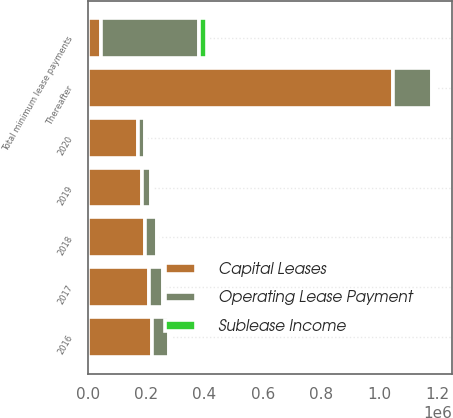Convert chart. <chart><loc_0><loc_0><loc_500><loc_500><stacked_bar_chart><ecel><fcel>2016<fcel>2017<fcel>2018<fcel>2019<fcel>2020<fcel>Thereafter<fcel>Total minimum lease payments<nl><fcel>Capital Leases<fcel>220357<fcel>208975<fcel>196632<fcel>184157<fcel>171794<fcel>1.0467e+06<fcel>44456.5<nl><fcel>Sublease Income<fcel>4827<fcel>4354<fcel>3316<fcel>2864<fcel>2922<fcel>10327<fcel>28610<nl><fcel>Operating Lease Payment<fcel>56543<fcel>49217<fcel>39696<fcel>31909<fcel>24418<fcel>134532<fcel>336315<nl></chart> 